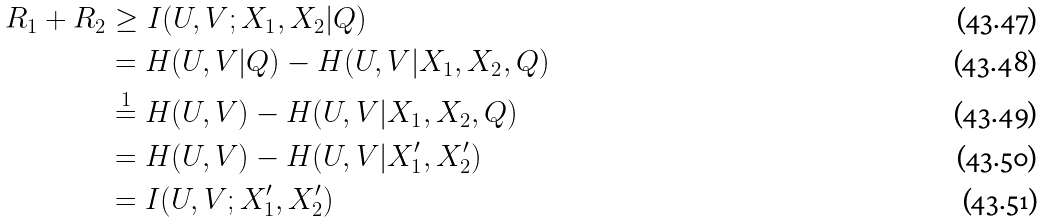<formula> <loc_0><loc_0><loc_500><loc_500>R _ { 1 } + R _ { 2 } & \geq I ( U , V ; X _ { 1 } , X _ { 2 } | Q ) \\ & = H ( U , V | Q ) - H ( U , V | X _ { 1 } , X _ { 2 } , Q ) \\ & \overset { 1 } { = } H ( U , V ) - H ( U , V | X _ { 1 } , X _ { 2 } , Q ) \\ & = H ( U , V ) - H ( U , V | X _ { 1 } ^ { \prime } , X _ { 2 } ^ { \prime } ) \\ & = I ( U , V ; X _ { 1 } ^ { \prime } , X _ { 2 } ^ { \prime } )</formula> 